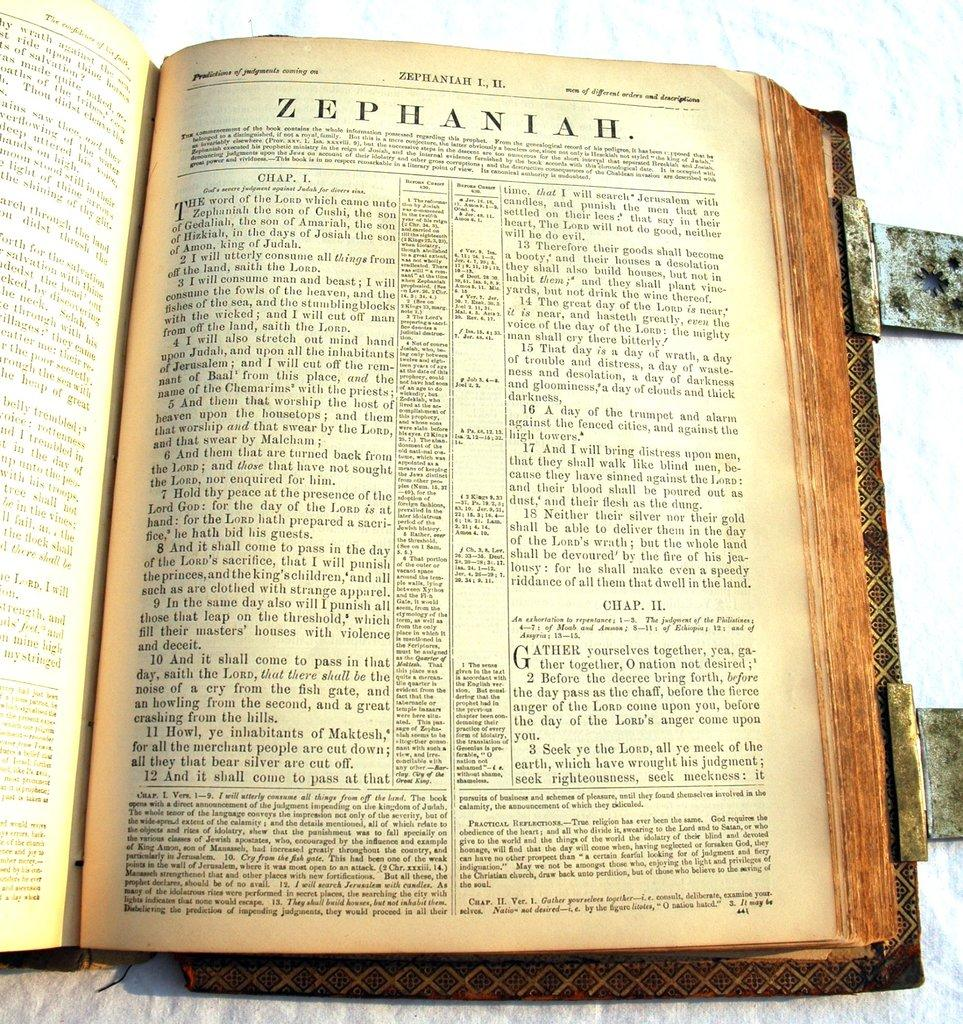<image>
Summarize the visual content of the image. an old open book with the page open to a ZEPHANIAH wording at the top. 